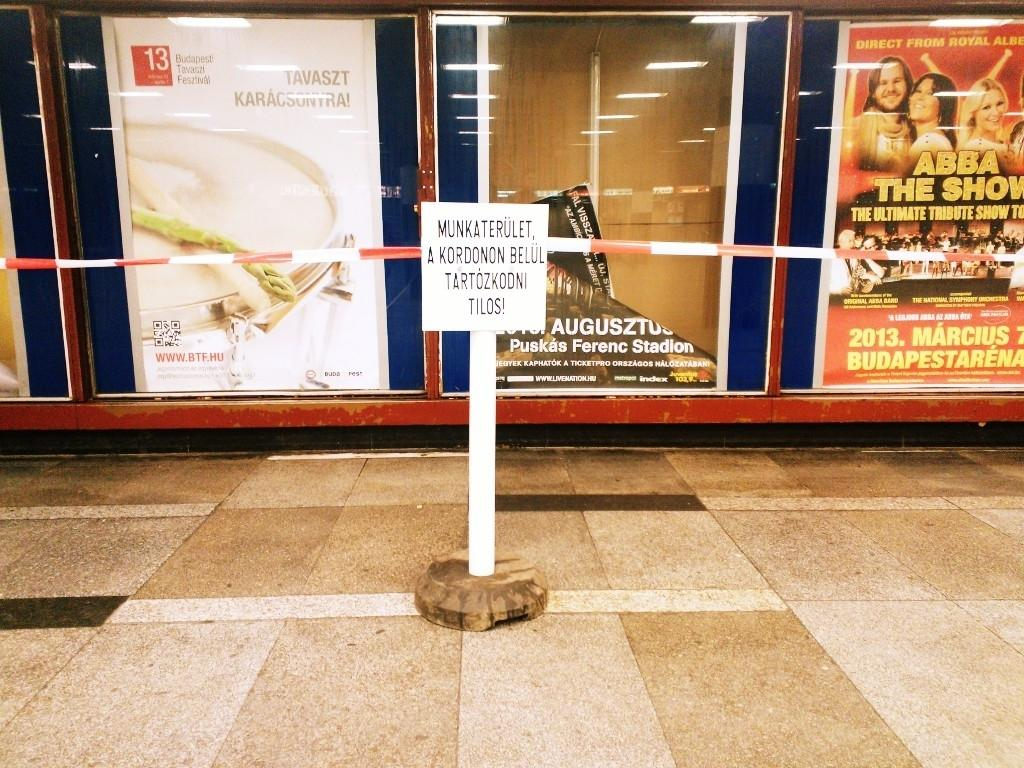<image>
Offer a succinct explanation of the picture presented. A sign on the tile in front of advertisements that say munkaterulet. 